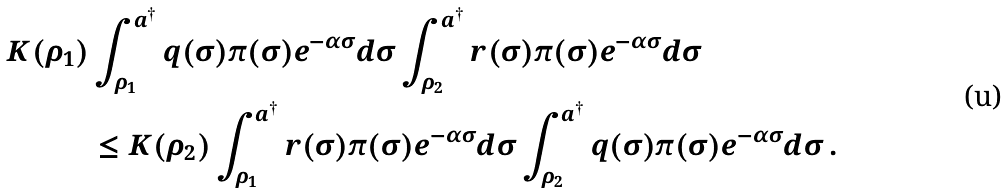<formula> <loc_0><loc_0><loc_500><loc_500>K ( \rho _ { 1 } ) & \int _ { \rho _ { 1 } } ^ { a ^ { \dagger } } q ( \sigma ) \pi ( \sigma ) e ^ { - \alpha \sigma } d \sigma \int _ { \rho _ { 2 } } ^ { a ^ { \dagger } } r ( \sigma ) \pi ( \sigma ) e ^ { - \alpha \sigma } d \sigma \\ & \leq K ( \rho _ { 2 } ) \int _ { \rho _ { 1 } } ^ { a ^ { \dagger } } r ( \sigma ) \pi ( \sigma ) e ^ { - \alpha \sigma } d \sigma \int _ { \rho _ { 2 } } ^ { a ^ { \dagger } } q ( \sigma ) \pi ( \sigma ) e ^ { - \alpha \sigma } d \sigma \, .</formula> 